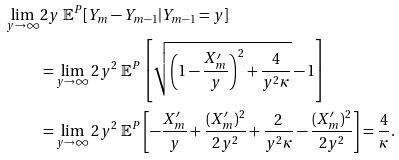Convert formula to latex. <formula><loc_0><loc_0><loc_500><loc_500>\lim _ { y \to \infty } & 2 y \ \mathbb { E } ^ { P } [ Y _ { m } - Y _ { m - 1 } | Y _ { m - 1 } = y ] \\ & = \lim _ { y \to \infty } 2 y ^ { 2 } \ \mathbb { E } ^ { P } \left [ \sqrt { \left ( 1 - \frac { X _ { m } ^ { \prime } } { y } \right ) ^ { 2 } + \frac { 4 } { y ^ { 2 } \kappa } } - 1 \right ] \\ & = \lim _ { y \to \infty } 2 y ^ { 2 } \ \mathbb { E } ^ { P } \left [ - \frac { X _ { m } ^ { \prime } } y + \frac { ( X _ { m } ^ { \prime } ) ^ { 2 } } { 2 y ^ { 2 } } + \frac { 2 } { y ^ { 2 } \kappa } - \frac { ( X _ { m } ^ { \prime } ) ^ { 2 } } { 2 y ^ { 2 } } \right ] = \frac { 4 } { \kappa } .</formula> 